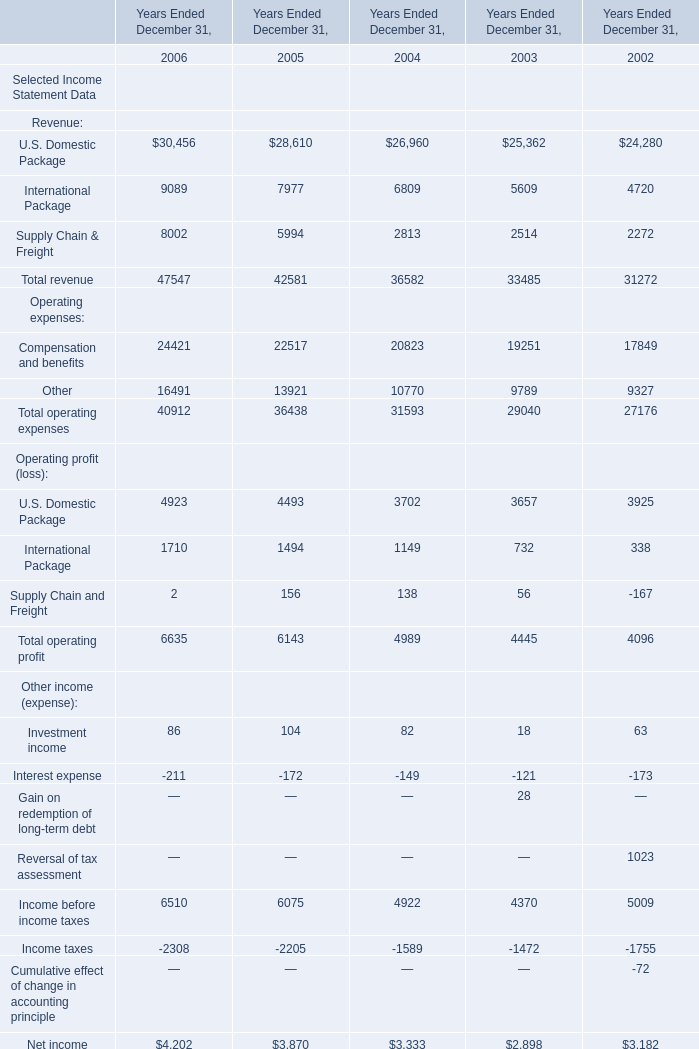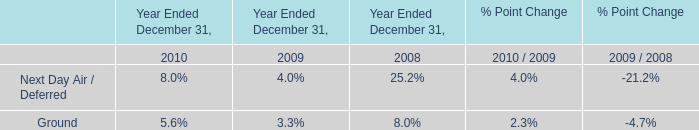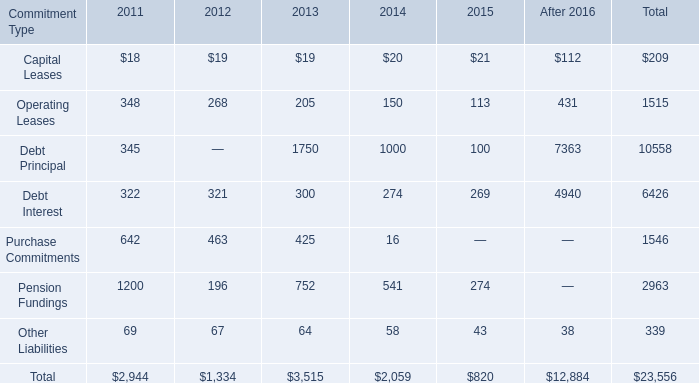What was the total amount of Investment income , Interest expense, Income before income taxes and Income taxes in 2005 for Other income (expense)? 
Computations: (((104 - 172) + 6075) - 2205)
Answer: 3802.0. 